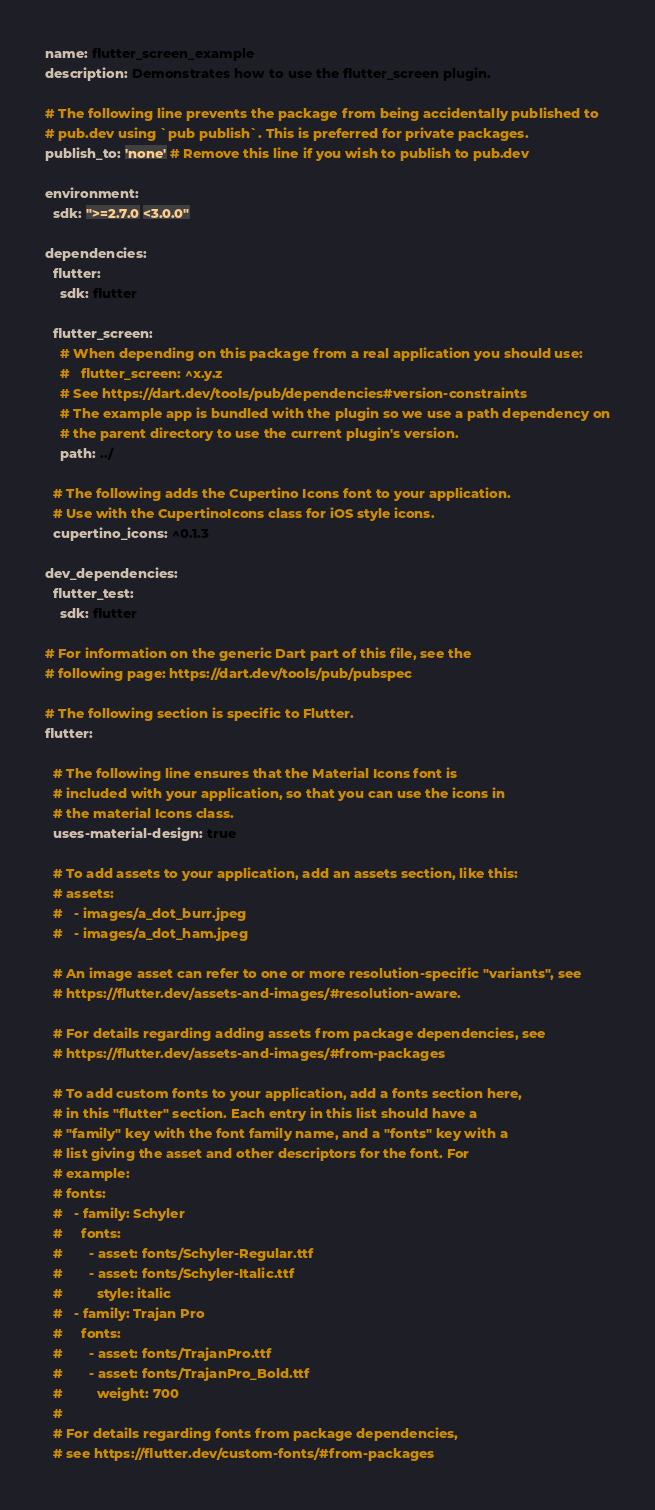<code> <loc_0><loc_0><loc_500><loc_500><_YAML_>name: flutter_screen_example
description: Demonstrates how to use the flutter_screen plugin.

# The following line prevents the package from being accidentally published to
# pub.dev using `pub publish`. This is preferred for private packages.
publish_to: 'none' # Remove this line if you wish to publish to pub.dev

environment:
  sdk: ">=2.7.0 <3.0.0"

dependencies:
  flutter:
    sdk: flutter

  flutter_screen:
    # When depending on this package from a real application you should use:
    #   flutter_screen: ^x.y.z
    # See https://dart.dev/tools/pub/dependencies#version-constraints
    # The example app is bundled with the plugin so we use a path dependency on
    # the parent directory to use the current plugin's version. 
    path: ../

  # The following adds the Cupertino Icons font to your application.
  # Use with the CupertinoIcons class for iOS style icons.
  cupertino_icons: ^0.1.3

dev_dependencies:
  flutter_test:
    sdk: flutter

# For information on the generic Dart part of this file, see the
# following page: https://dart.dev/tools/pub/pubspec

# The following section is specific to Flutter.
flutter:

  # The following line ensures that the Material Icons font is
  # included with your application, so that you can use the icons in
  # the material Icons class.
  uses-material-design: true

  # To add assets to your application, add an assets section, like this:
  # assets:
  #   - images/a_dot_burr.jpeg
  #   - images/a_dot_ham.jpeg

  # An image asset can refer to one or more resolution-specific "variants", see
  # https://flutter.dev/assets-and-images/#resolution-aware.

  # For details regarding adding assets from package dependencies, see
  # https://flutter.dev/assets-and-images/#from-packages

  # To add custom fonts to your application, add a fonts section here,
  # in this "flutter" section. Each entry in this list should have a
  # "family" key with the font family name, and a "fonts" key with a
  # list giving the asset and other descriptors for the font. For
  # example:
  # fonts:
  #   - family: Schyler
  #     fonts:
  #       - asset: fonts/Schyler-Regular.ttf
  #       - asset: fonts/Schyler-Italic.ttf
  #         style: italic
  #   - family: Trajan Pro
  #     fonts:
  #       - asset: fonts/TrajanPro.ttf
  #       - asset: fonts/TrajanPro_Bold.ttf
  #         weight: 700
  #
  # For details regarding fonts from package dependencies,
  # see https://flutter.dev/custom-fonts/#from-packages
</code> 